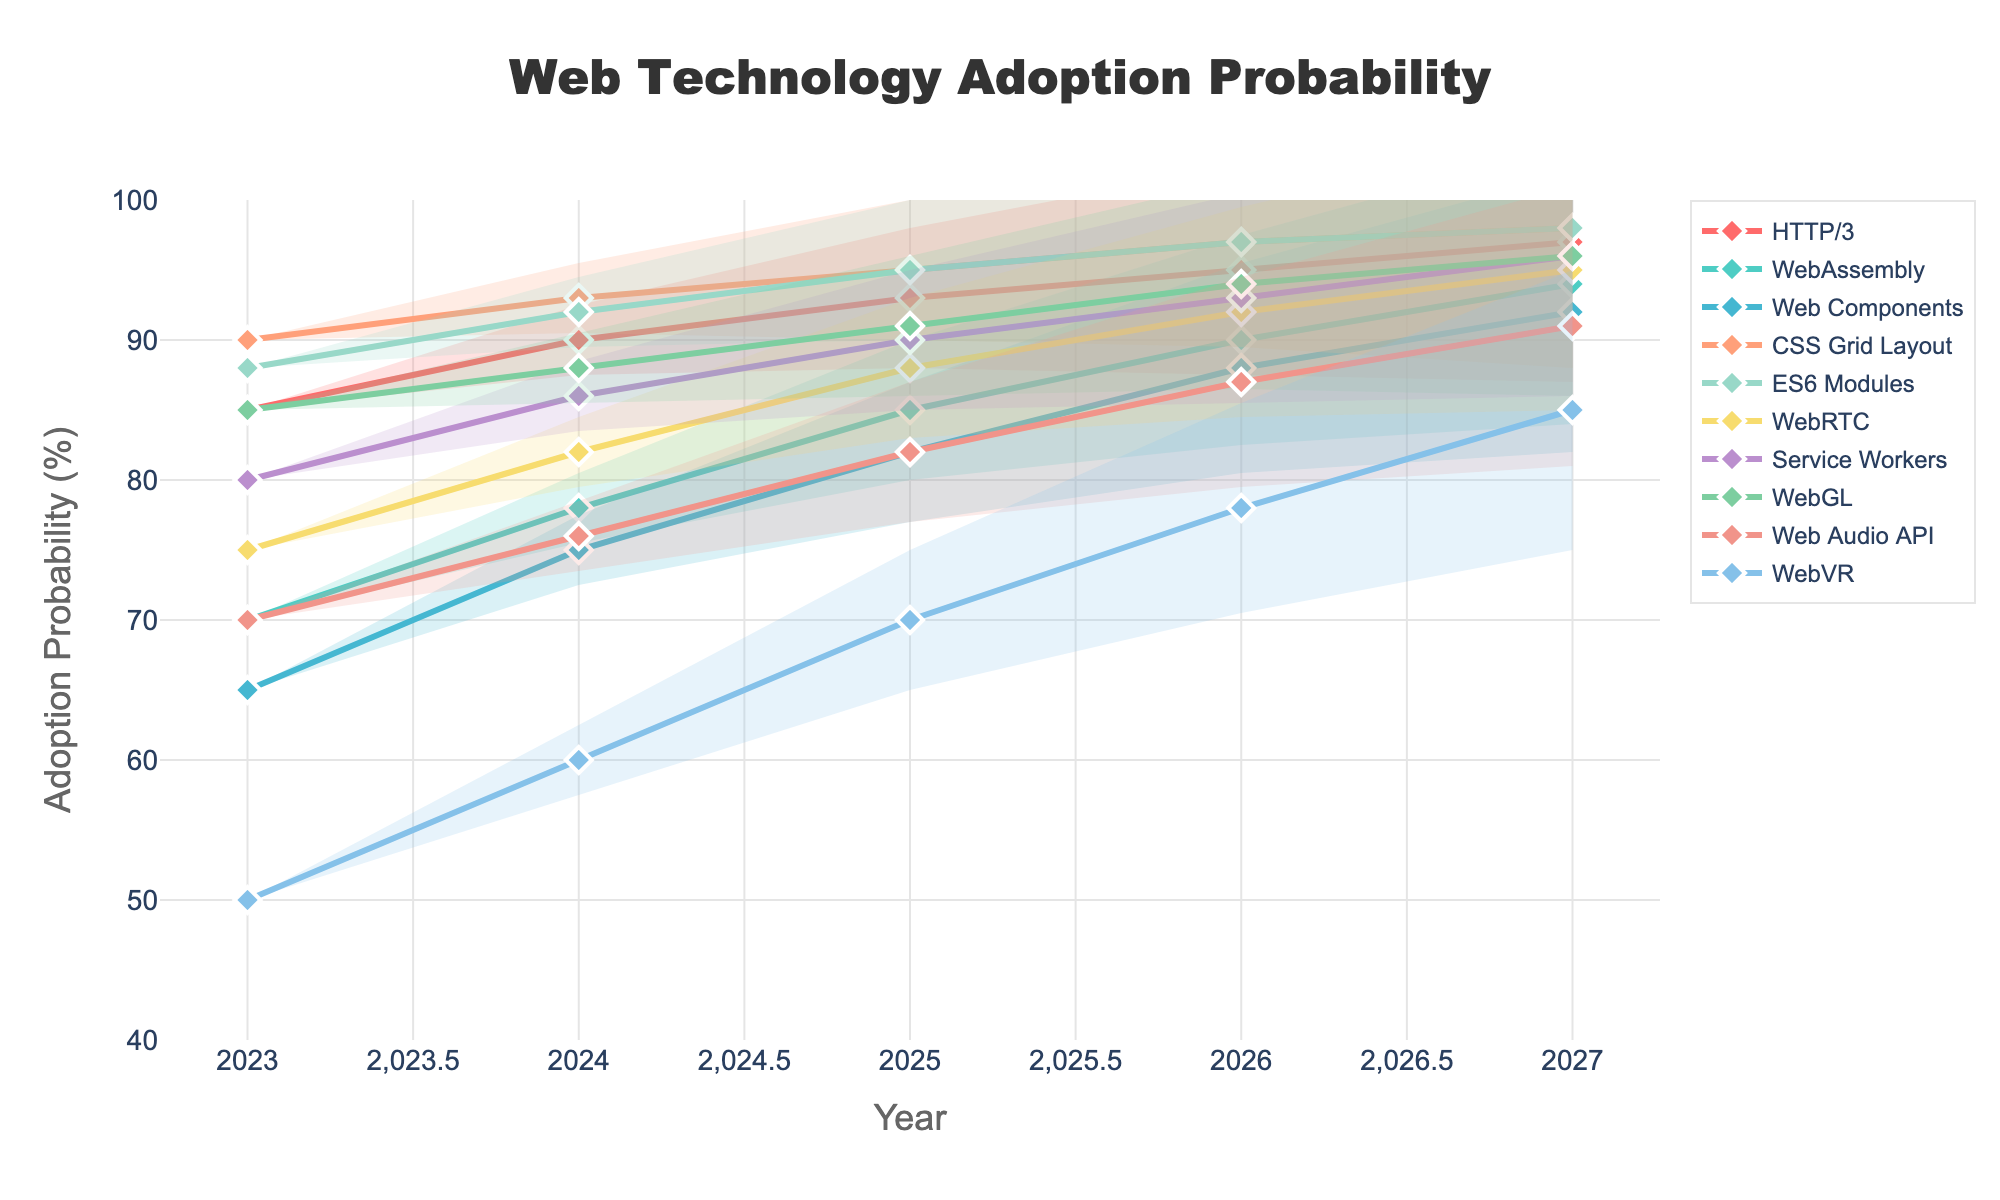What's the title of the chart? The title of the chart is typically found at the top or center of the figure. In this case, it is specified as "Web Technology Adoption Probability".
Answer: Web Technology Adoption Probability Which technology has the highest adoption probability by 2027? By examining all the adoption probabilities shown on the chart for the year 2027, the highest value is 98%, which corresponds to "CSS Grid Layout" and "ES6 Modules".
Answer: CSS Grid Layout and ES6 Modules What is the adoption probability interval for WebAssembly in 2024? In the fan chart, the adoption probability interval for WebAssembly in 2024 is depicted by the upper and lower bounds of the shaded area around the central line for that year. From the provided data, the probability is 78%, with the interval ranging approximately from 68% to 88% due to the fan spread.
Answer: 68% to 88% Which technology shows the most significant growth in adoption probability from 2023 to 2027? To determine this, calculate the difference between the 2023 and 2027 adoption probabilities for each technology. WebVR shows the largest increase, growing from 50% in 2023 to 85% in 2027, an increase of 35%.
Answer: WebVR What is the general trend for Service Workers' adoption probability over the years? The trend for Service Workers, as indicated by the consistently rising line from 2023 to 2027, shows a general increase in adoption probability, starting from 80% in 2023 and reaching 96% by 2027.
Answer: Increasing Which technology has the smallest increase in adoption probability over the given years? By comparing the increase for all technologies from 2023 to 2027, CSS Grid Layout has the smallest increase, from 90% to 98%, an increase of 8%.
Answer: CSS Grid Layout How does the adoption probability of WebRTC in 2025 compare to that of WebGL in the same year? By locating the values for both technologies in the year 2025 on the chart, WebRTC has an adoption probability of 88% while WebGL has 91%. Therefore, WebGL's probability is higher.
Answer: WebGL has a higher probability What adoption probability is the midpoint of the upper and lower bounds for HTTP/3 in 2025? Calculate the midpoint of the upper and lower bounds for HTTP/3 in 2025. Given HTTP/3's probability is 93%, with bounds approximately 88% to 98% due to the fan spread, the midpoint (88% + 98%) / 2 = 93%.
Answer: 93% How many technologies exceed a 90% adoption probability level by 2026? Evaluate the adoption probabilities for each technology in 2026. Technologies that exceed 90% are HTTP/3, Web Components, CSS Grid Layout, ES6 Modules, WebRTC, Service Workers, and WebGL. There are 7 such technologies.
Answer: 7 Which technology demonstrates a steadier increase without significant fluctuations? A steady increase without significant fluctuations is indicated by a consistent, upward trend line on the chart. "Service Workers" has a noticeably smooth and steadily rising line from 2023 to 2027, implying steady increase.
Answer: Service Workers 